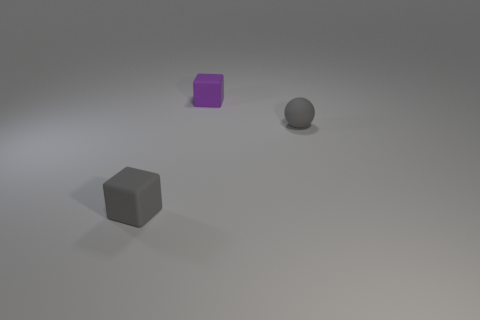What is the shape of the thing behind the tiny gray thing that is right of the purple matte block?
Provide a short and direct response. Cube. What is the size of the gray sphere?
Ensure brevity in your answer.  Small. What is the shape of the purple rubber object?
Your response must be concise. Cube. Do the purple rubber object and the small matte thing on the left side of the tiny purple cube have the same shape?
Your response must be concise. Yes. There is a gray thing that is on the left side of the gray rubber sphere; does it have the same shape as the purple thing?
Provide a succinct answer. Yes. How many rubber blocks are both in front of the small purple rubber object and behind the gray matte block?
Keep it short and to the point. 0. How many other objects are the same size as the gray sphere?
Your response must be concise. 2. Are there the same number of tiny objects that are in front of the tiny gray matte ball and purple matte cubes?
Give a very brief answer. Yes. There is a rubber cube on the left side of the tiny purple object; is it the same color as the tiny object that is on the right side of the tiny purple cube?
Offer a very short reply. Yes. What material is the tiny thing that is in front of the small purple rubber object and on the left side of the gray sphere?
Ensure brevity in your answer.  Rubber. 